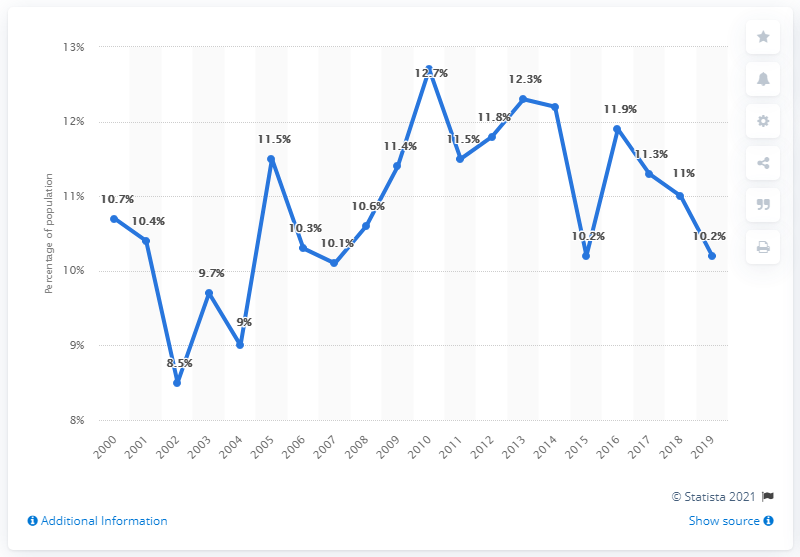Indicate a few pertinent items in this graphic. The poverty rate reached its peak in 2010. In the last three years, the average poverty rate was 10.83%. 